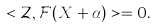Convert formula to latex. <formula><loc_0><loc_0><loc_500><loc_500>< \mathcal { Z } , \mathcal { F } ( X + \alpha ) > = 0 .</formula> 